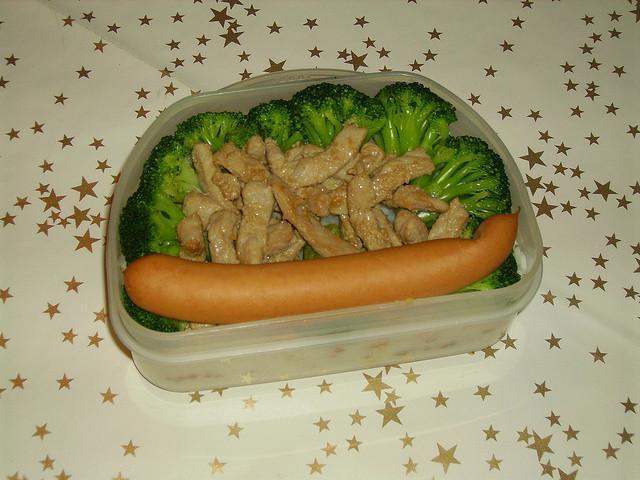Is the caption "The bowl is next to the hot dog." a true representation of the image?
Answer yes or no. No. Does the image validate the caption "The hot dog is in the bowl."?
Answer yes or no. Yes. Evaluate: Does the caption "The dining table is touching the bowl." match the image?
Answer yes or no. Yes. 